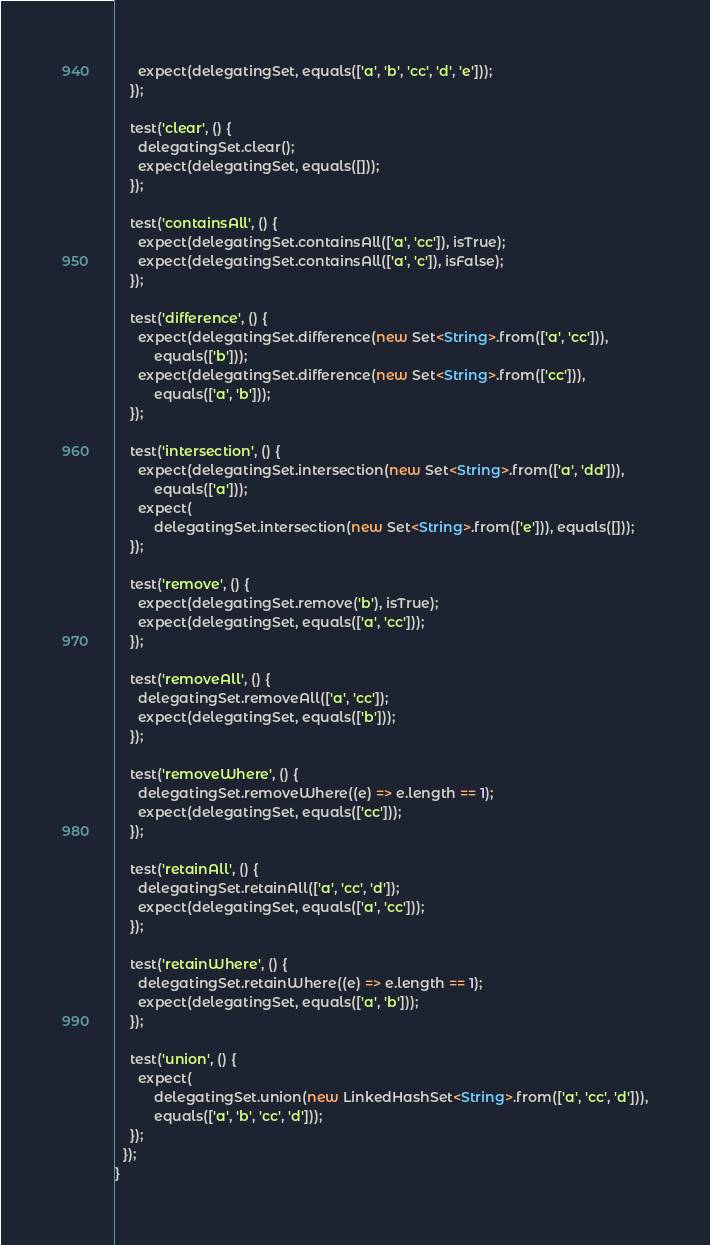<code> <loc_0><loc_0><loc_500><loc_500><_Dart_>      expect(delegatingSet, equals(['a', 'b', 'cc', 'd', 'e']));
    });

    test('clear', () {
      delegatingSet.clear();
      expect(delegatingSet, equals([]));
    });

    test('containsAll', () {
      expect(delegatingSet.containsAll(['a', 'cc']), isTrue);
      expect(delegatingSet.containsAll(['a', 'c']), isFalse);
    });

    test('difference', () {
      expect(delegatingSet.difference(new Set<String>.from(['a', 'cc'])),
          equals(['b']));
      expect(delegatingSet.difference(new Set<String>.from(['cc'])),
          equals(['a', 'b']));
    });

    test('intersection', () {
      expect(delegatingSet.intersection(new Set<String>.from(['a', 'dd'])),
          equals(['a']));
      expect(
          delegatingSet.intersection(new Set<String>.from(['e'])), equals([]));
    });

    test('remove', () {
      expect(delegatingSet.remove('b'), isTrue);
      expect(delegatingSet, equals(['a', 'cc']));
    });

    test('removeAll', () {
      delegatingSet.removeAll(['a', 'cc']);
      expect(delegatingSet, equals(['b']));
    });

    test('removeWhere', () {
      delegatingSet.removeWhere((e) => e.length == 1);
      expect(delegatingSet, equals(['cc']));
    });

    test('retainAll', () {
      delegatingSet.retainAll(['a', 'cc', 'd']);
      expect(delegatingSet, equals(['a', 'cc']));
    });

    test('retainWhere', () {
      delegatingSet.retainWhere((e) => e.length == 1);
      expect(delegatingSet, equals(['a', 'b']));
    });

    test('union', () {
      expect(
          delegatingSet.union(new LinkedHashSet<String>.from(['a', 'cc', 'd'])),
          equals(['a', 'b', 'cc', 'd']));
    });
  });
}
</code> 